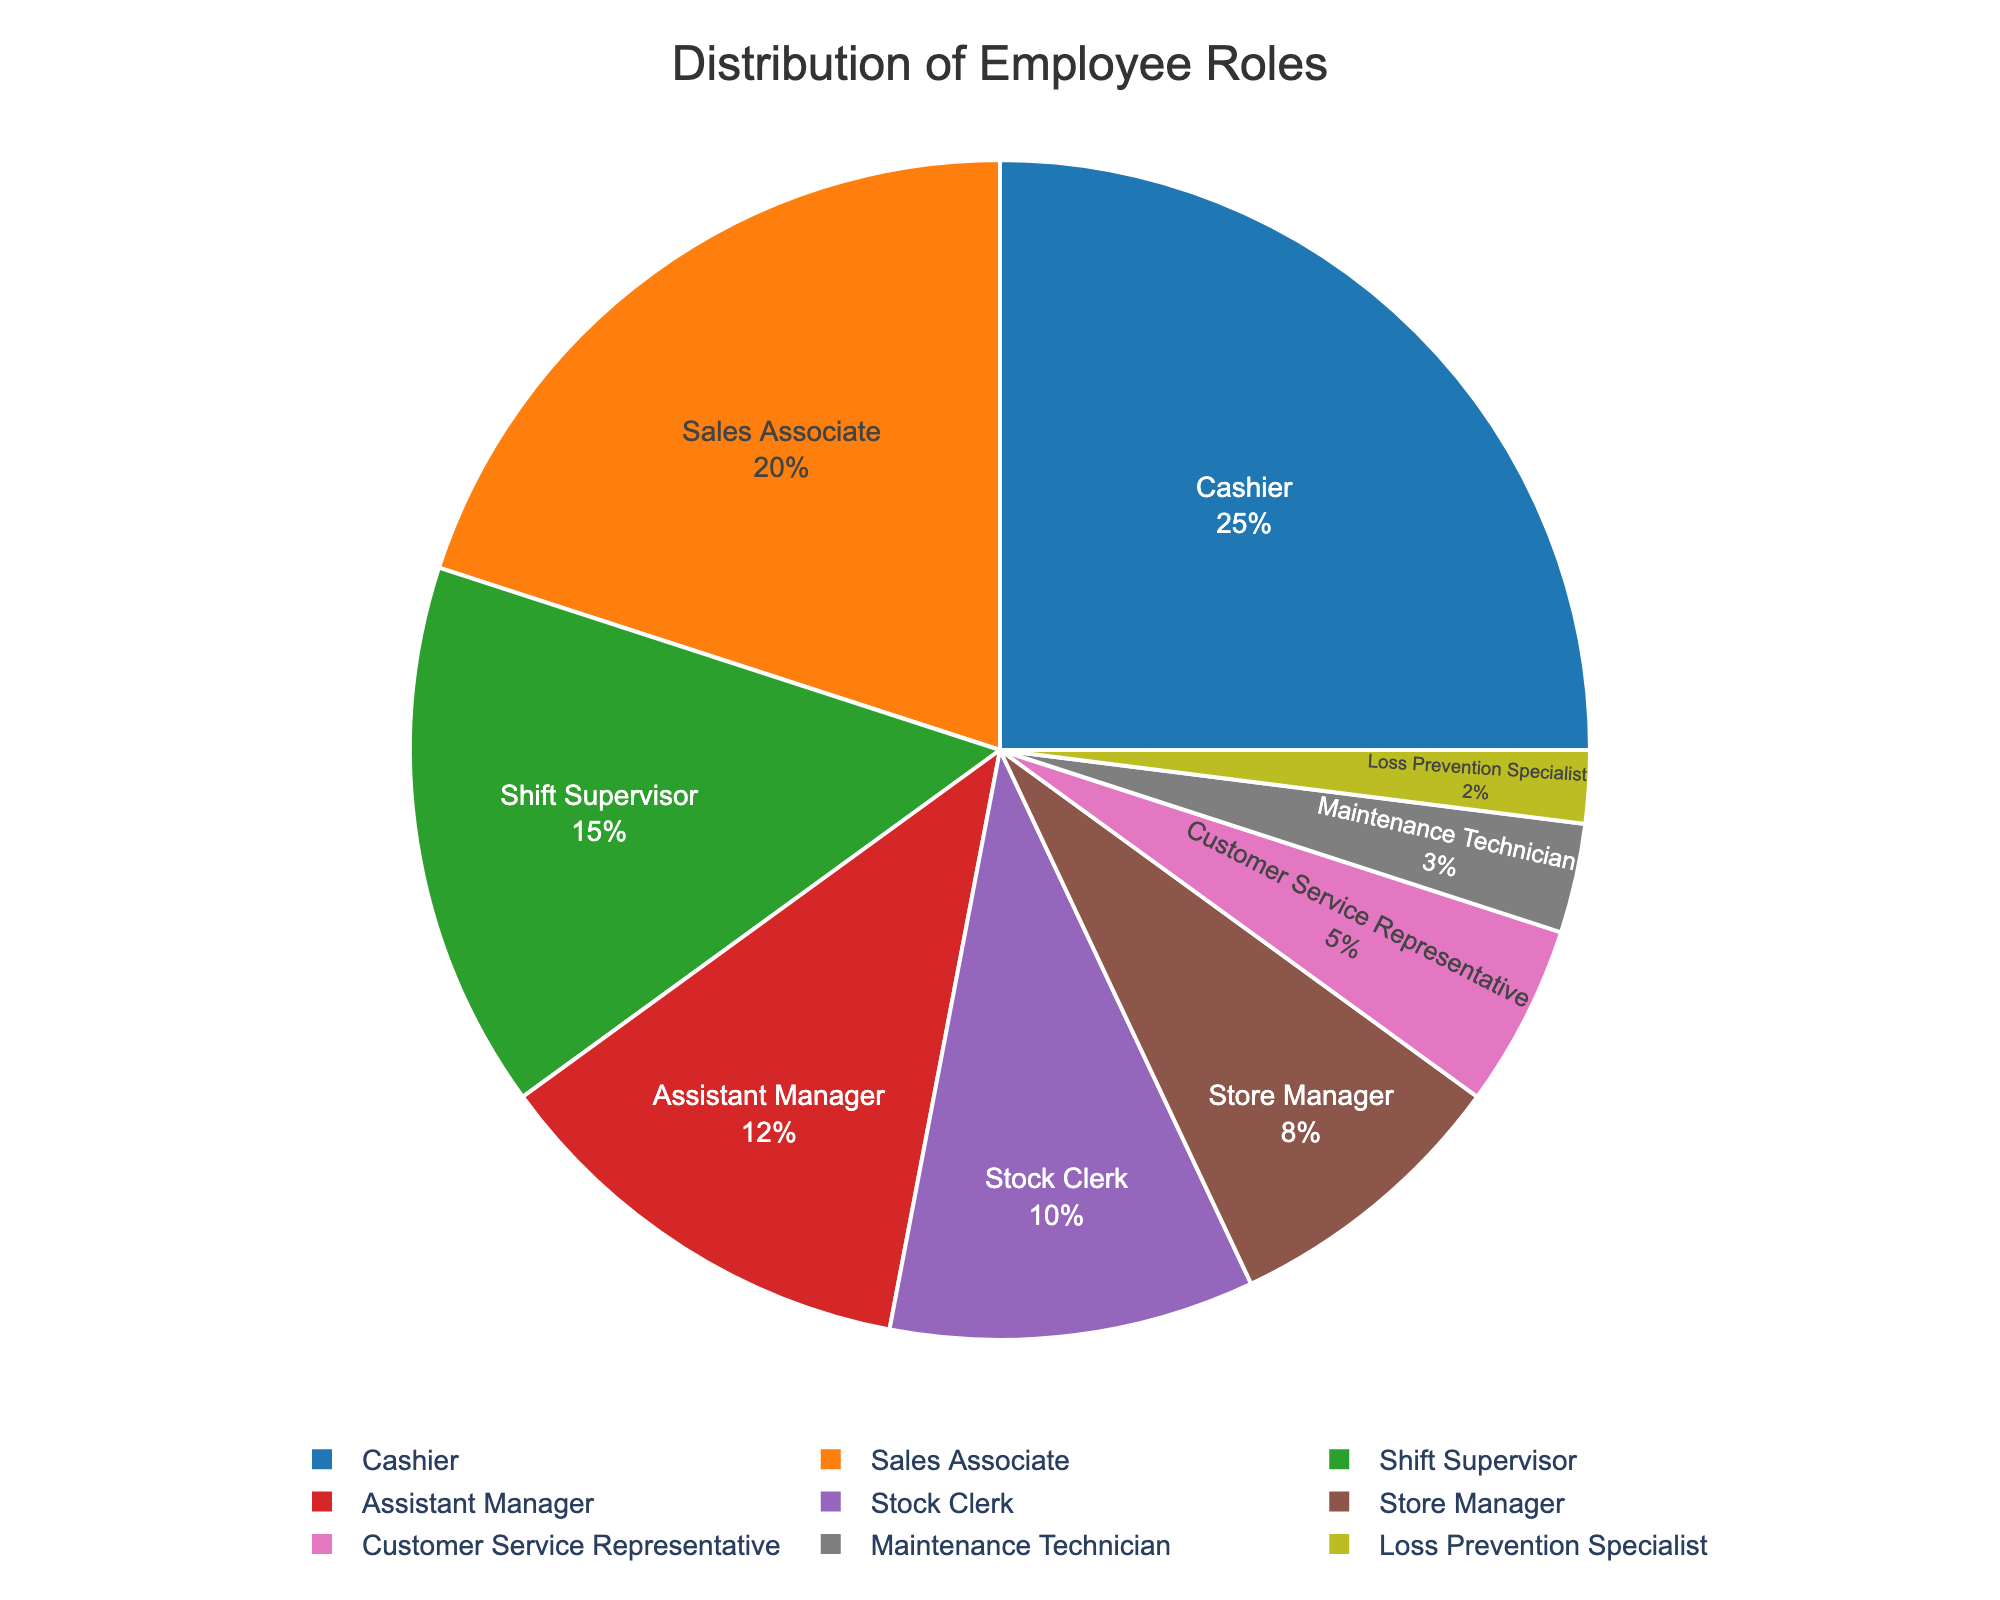What percentage of the roles are managerial positions (Store Manager and Assistant Manager)? To find the percentage of managerial positions, sum the percentages of the roles categorized under managerial positions: Store Manager (8%) and Assistant Manager (12%). 8% + 12% = 20%.
Answer: 20% Which role has the highest percentage? From the pie chart, identify the segment with the largest size or the highest value. In this case, the role with the highest percentage is Cashier at 25%.
Answer: Cashier By how much does the percentage of Cashiers exceed that of Shift Supervisors? Subtract the percentage of Shift Supervisors from that of Cashiers. Cashier: 25%, Shift Supervisor: 15%. 25% - 15% = 10%.
Answer: 10% What is the combined percentage of Sales Associates and Stock Clerks? Add the percentages of Sales Associates (20%) and Stock Clerks (10%). 20% + 10% = 30%.
Answer: 30% Is the percentage of Maintenance Technicians higher than that of Loss Prevention Specialists? Compare the percentages of both roles. Maintenance Technician: 3%, Loss Prevention Specialist: 2%. 3% is greater than 2%.
Answer: Yes Which roles have a percentage below 10% and what are their combined percentages? Identify the roles with percentages below 10%: Stock Clerk (10% exactly is not included), Customer Service Representative (5%), Maintenance Technician (3%), Loss Prevention Specialist (2%). Add these percentages: 5% + 3% + 2% = 10%.
Answer: Customer Service Representative, Maintenance Technician, Loss Prevention Specialist, 10% What percentage of the roles consists of Cashiers or Sales Associates? Add the percentages of Cashiers (25%) and Sales Associates (20%). 25% + 20% = 45%.
Answer: 45% How does the percentage of Sales Associates compare to that of Stock Clerks? Compare the percentages of both roles. Sales Associate: 20%, Stock Clerk: 10%. 20% is greater than 10%.
Answer: Sales Associate has a higher percentage What is the smallest percentage among all roles, and which role does it correspond to? Identify the smallest segment in the pie chart. The smallest percentage is 2%, corresponding to Loss Prevention Specialist.
Answer: 2%, Loss Prevention Specialist 